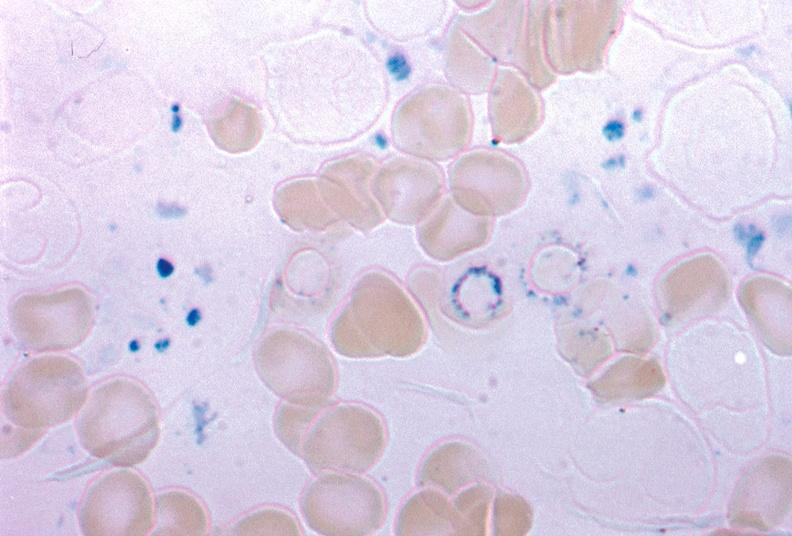s sideroblasts present?
Answer the question using a single word or phrase. Yes 